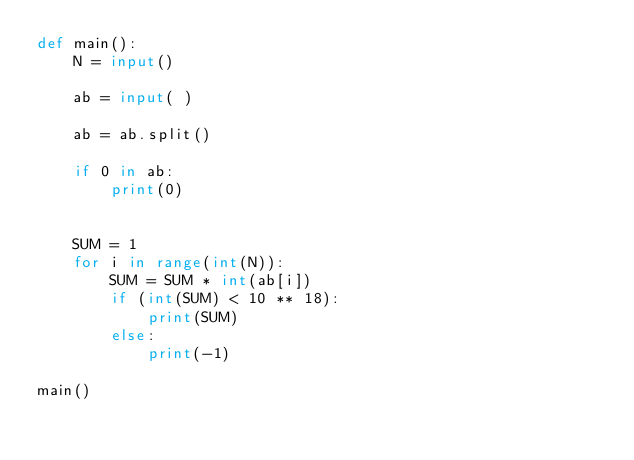<code> <loc_0><loc_0><loc_500><loc_500><_Python_>def main():
    N = input()

    ab = input( )

    ab = ab.split()
    
    if 0 in ab:
        print(0)


    SUM = 1
    for i in range(int(N)):
        SUM = SUM * int(ab[i])
        if (int(SUM) < 10 ** 18):
            print(SUM)
        else:
            print(-1)
        
main()</code> 